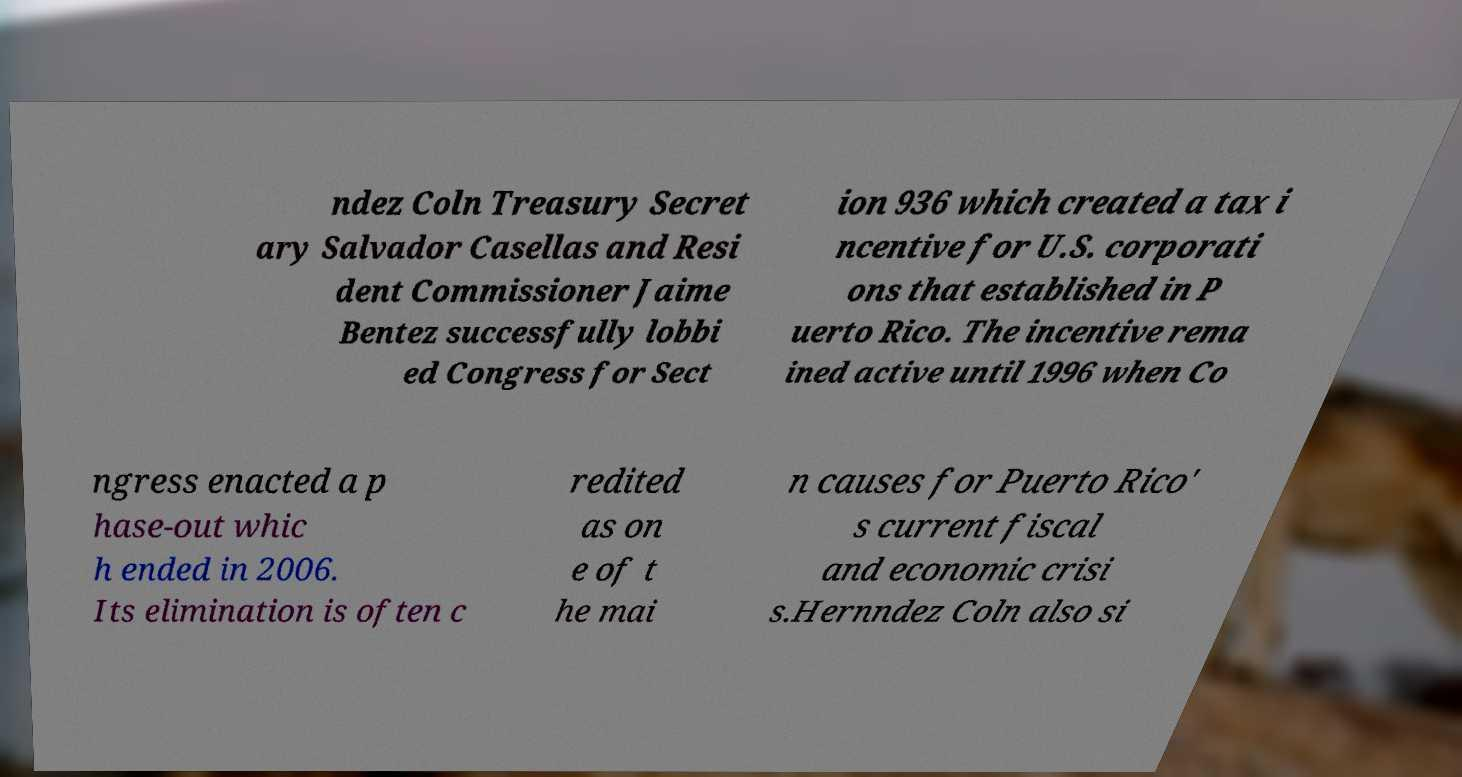What messages or text are displayed in this image? I need them in a readable, typed format. ndez Coln Treasury Secret ary Salvador Casellas and Resi dent Commissioner Jaime Bentez successfully lobbi ed Congress for Sect ion 936 which created a tax i ncentive for U.S. corporati ons that established in P uerto Rico. The incentive rema ined active until 1996 when Co ngress enacted a p hase-out whic h ended in 2006. Its elimination is often c redited as on e of t he mai n causes for Puerto Rico' s current fiscal and economic crisi s.Hernndez Coln also si 